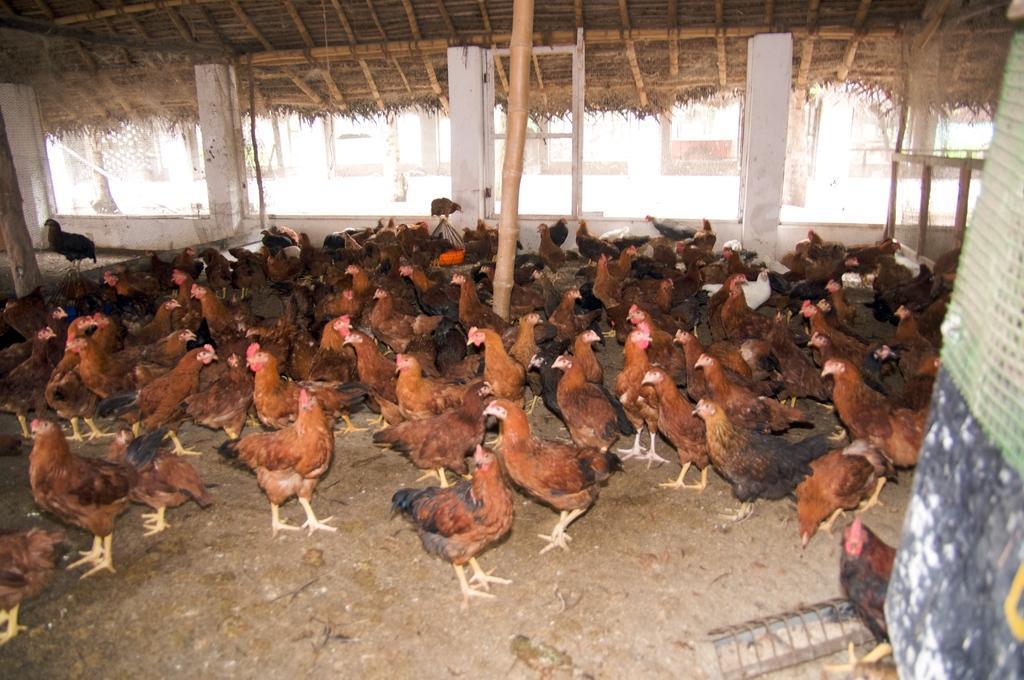Describe this image in one or two sentences. In this image we can see many hens on the ground. In the background we can see building. 